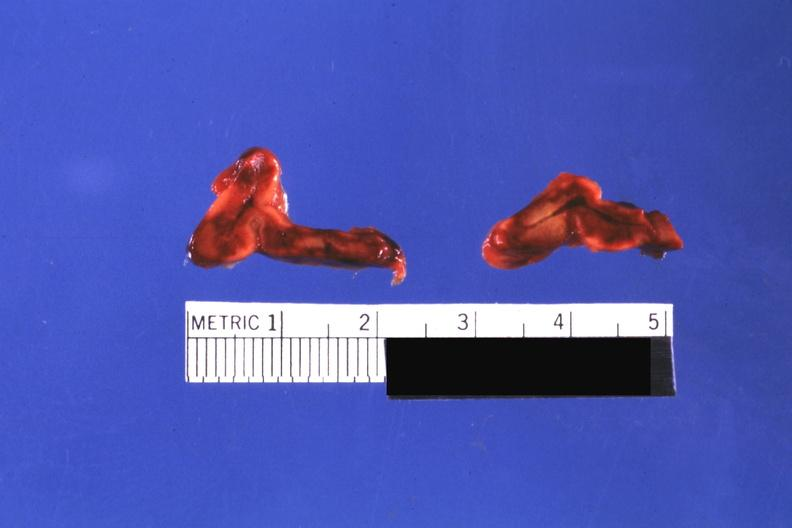does this image show cut surfaces of both adrenals focal hemorrhagic infarction well shown do not know history looks like placental abruption?
Answer the question using a single word or phrase. Yes 